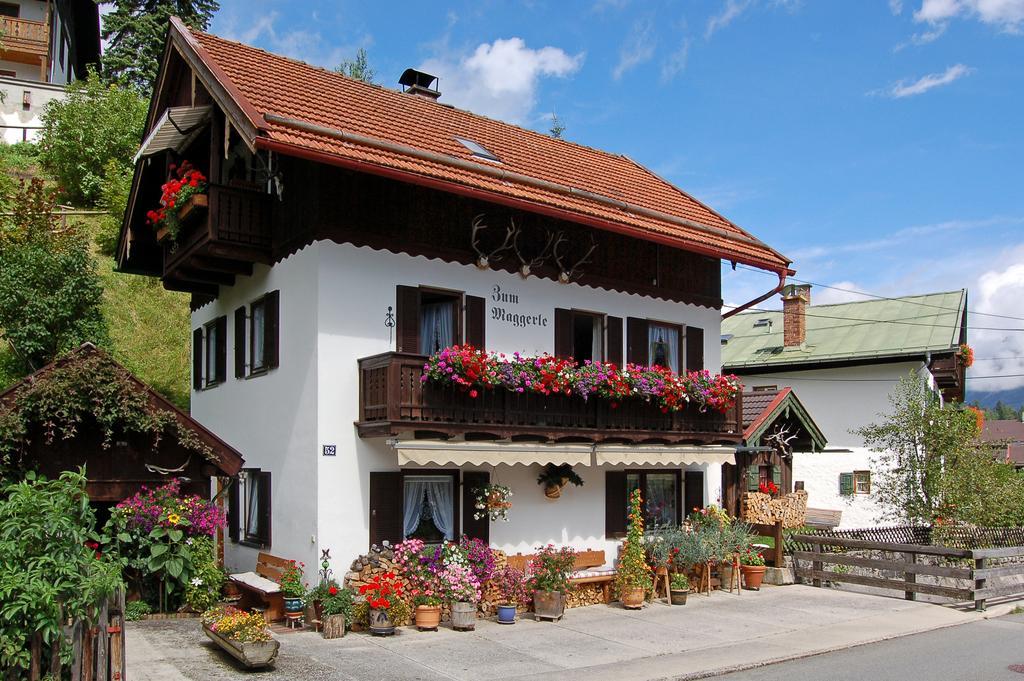Please provide a concise description of this image. In this picture we can see house plants, benches on the floor, fences, road, buildings, windows, curtains, trees, some objects and in the background we can see the sky with clouds. 